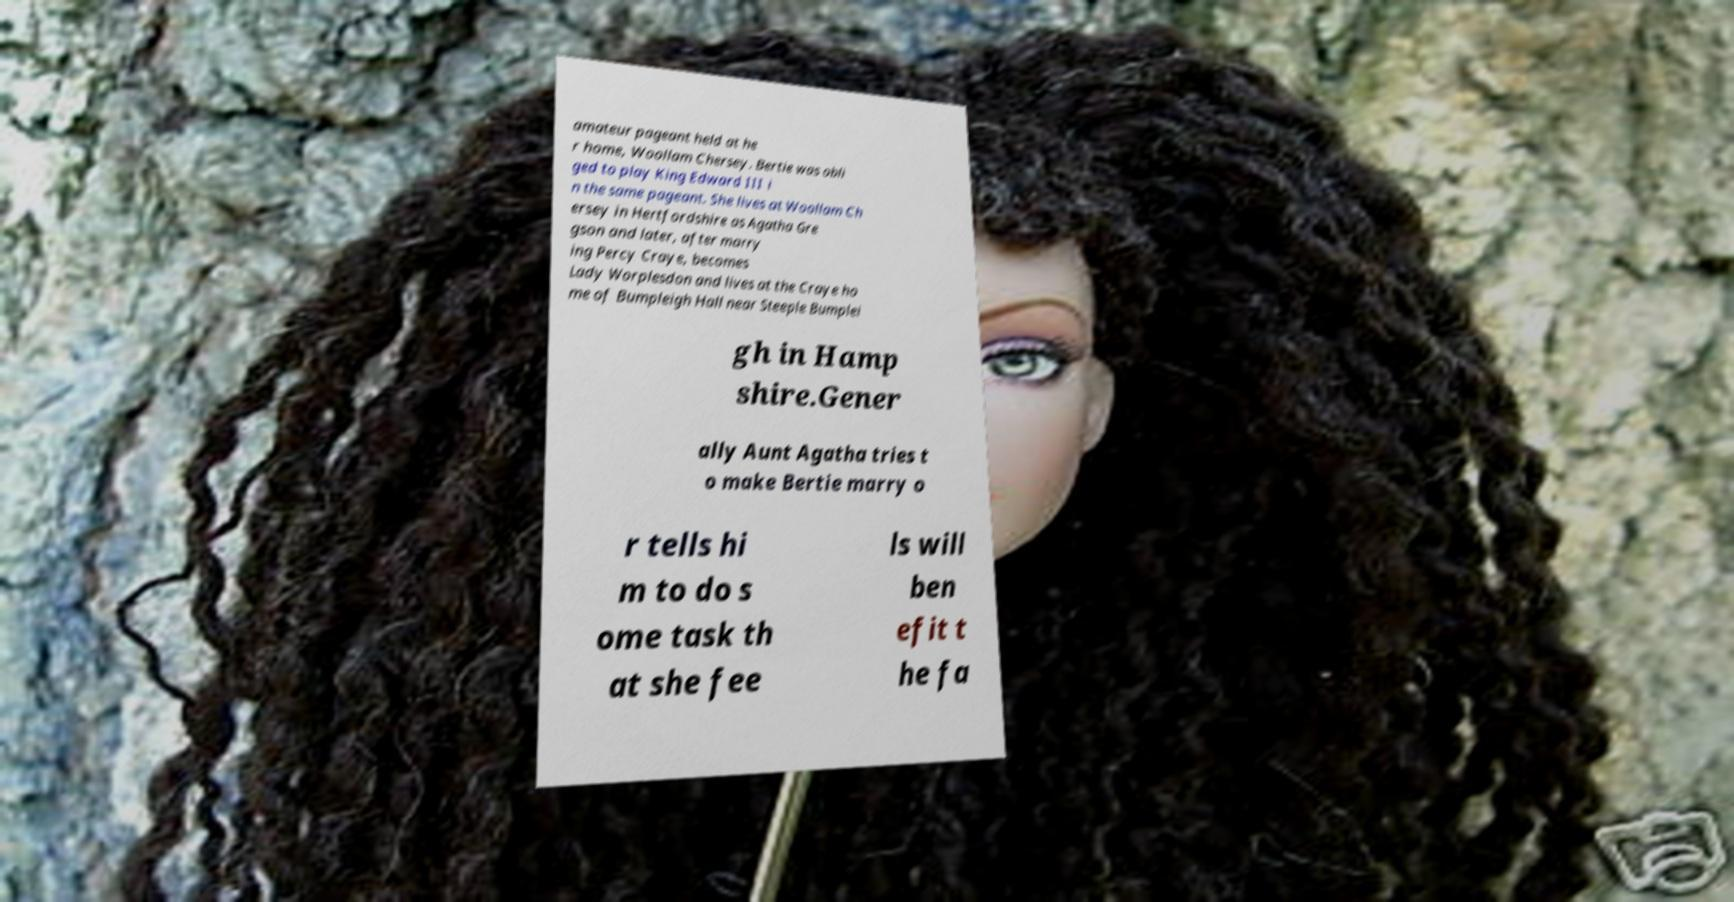What messages or text are displayed in this image? I need them in a readable, typed format. amateur pageant held at he r home, Woollam Chersey. Bertie was obli ged to play King Edward III i n the same pageant. She lives at Woollam Ch ersey in Hertfordshire as Agatha Gre gson and later, after marry ing Percy Craye, becomes Lady Worplesdon and lives at the Craye ho me of Bumpleigh Hall near Steeple Bumplei gh in Hamp shire.Gener ally Aunt Agatha tries t o make Bertie marry o r tells hi m to do s ome task th at she fee ls will ben efit t he fa 